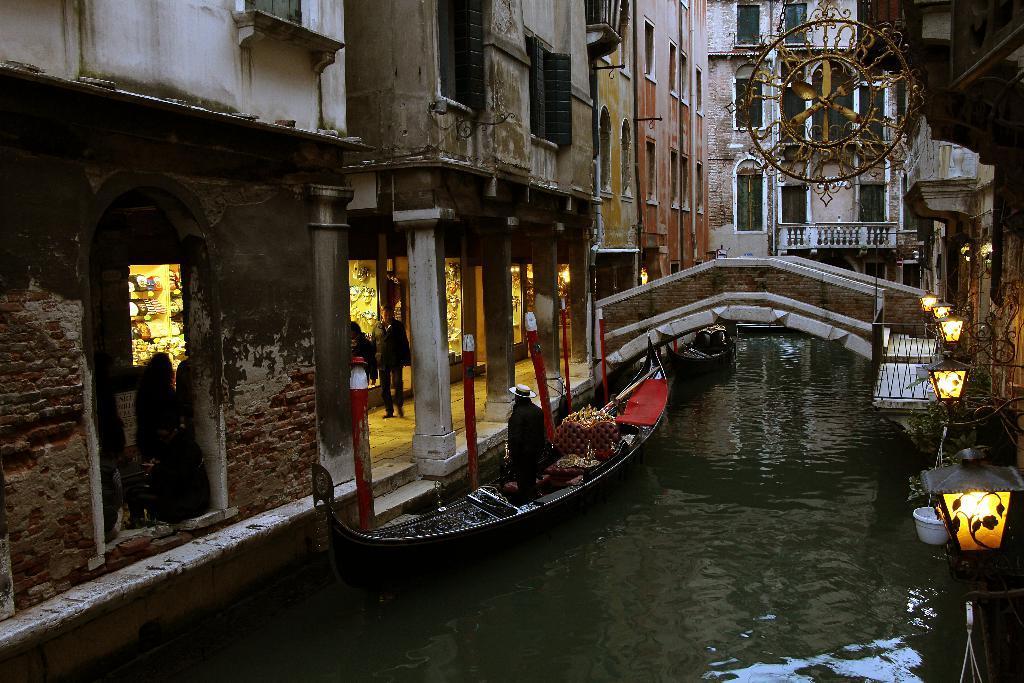In one or two sentences, can you explain what this image depicts? In this picture we can see a boat on the water, and we can find few people, beside to them we can see few metal rods, buildings, poles and lights, and also we can see a bridge over the water. 